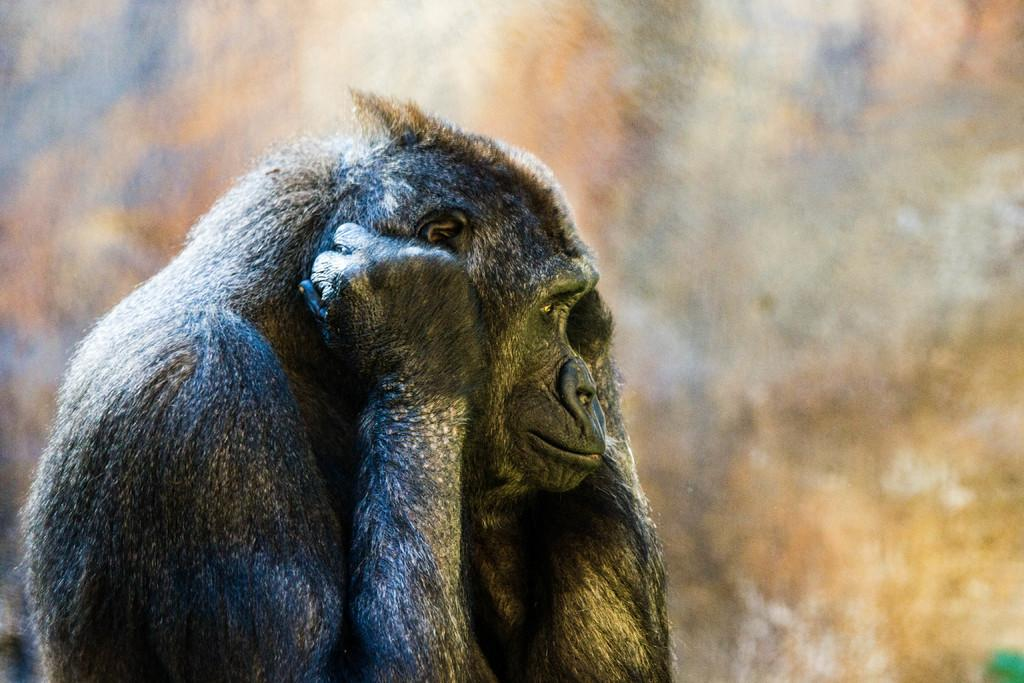What animal is located on the left side of the image? There is a chimpanzee on the left side of the image. Can you describe the background of the image? The background of the image is blurred. What type of kite is the chimpanzee holding in the image? There is no kite present in the image, and the chimpanzee is not holding anything. Is the chimpanzee coughing in the image? There is no indication in the image that the chimpanzee is coughing. 